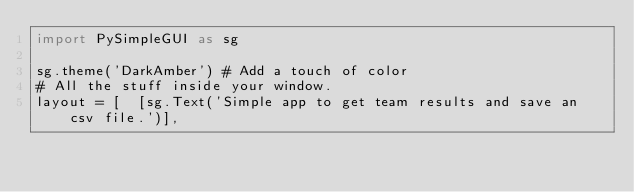<code> <loc_0><loc_0><loc_500><loc_500><_Python_>import PySimpleGUI as sg

sg.theme('DarkAmber')	# Add a touch of color
# All the stuff inside your window.
layout = [  [sg.Text('Simple app to get team results and save an csv file.')],</code> 